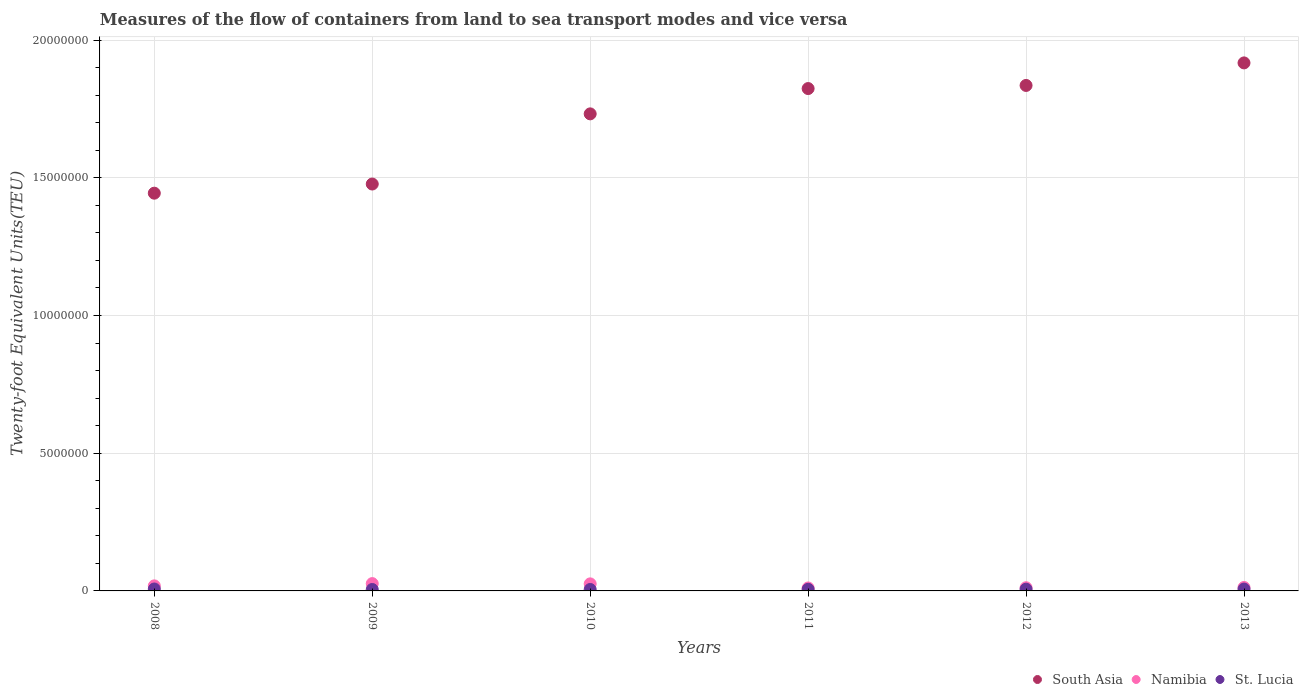What is the container port traffic in Namibia in 2011?
Make the answer very short. 1.08e+05. Across all years, what is the maximum container port traffic in South Asia?
Provide a short and direct response. 1.92e+07. Across all years, what is the minimum container port traffic in Namibia?
Your answer should be very brief. 1.08e+05. In which year was the container port traffic in South Asia minimum?
Your answer should be very brief. 2008. What is the total container port traffic in St. Lucia in the graph?
Offer a terse response. 3.64e+05. What is the difference between the container port traffic in South Asia in 2012 and that in 2013?
Offer a terse response. -8.18e+05. What is the difference between the container port traffic in Namibia in 2013 and the container port traffic in South Asia in 2012?
Give a very brief answer. -1.82e+07. What is the average container port traffic in Namibia per year?
Provide a short and direct response. 1.76e+05. In the year 2009, what is the difference between the container port traffic in South Asia and container port traffic in St. Lucia?
Make the answer very short. 1.47e+07. What is the ratio of the container port traffic in South Asia in 2008 to that in 2012?
Provide a succinct answer. 0.79. What is the difference between the highest and the second highest container port traffic in St. Lucia?
Your answer should be very brief. 2301.22. What is the difference between the highest and the lowest container port traffic in Namibia?
Ensure brevity in your answer.  1.58e+05. Is the sum of the container port traffic in Namibia in 2009 and 2012 greater than the maximum container port traffic in South Asia across all years?
Ensure brevity in your answer.  No. Is the container port traffic in South Asia strictly greater than the container port traffic in Namibia over the years?
Provide a succinct answer. Yes. Is the container port traffic in St. Lucia strictly less than the container port traffic in Namibia over the years?
Make the answer very short. Yes. How many dotlines are there?
Provide a succinct answer. 3. Are the values on the major ticks of Y-axis written in scientific E-notation?
Offer a terse response. No. Does the graph contain grids?
Your answer should be very brief. Yes. How are the legend labels stacked?
Offer a very short reply. Horizontal. What is the title of the graph?
Offer a terse response. Measures of the flow of containers from land to sea transport modes and vice versa. What is the label or title of the X-axis?
Your answer should be compact. Years. What is the label or title of the Y-axis?
Your answer should be very brief. Twenty-foot Equivalent Units(TEU). What is the Twenty-foot Equivalent Units(TEU) of South Asia in 2008?
Provide a short and direct response. 1.44e+07. What is the Twenty-foot Equivalent Units(TEU) in Namibia in 2008?
Give a very brief answer. 1.84e+05. What is the Twenty-foot Equivalent Units(TEU) in St. Lucia in 2008?
Provide a short and direct response. 7.02e+04. What is the Twenty-foot Equivalent Units(TEU) of South Asia in 2009?
Offer a very short reply. 1.48e+07. What is the Twenty-foot Equivalent Units(TEU) of Namibia in 2009?
Your answer should be compact. 2.66e+05. What is the Twenty-foot Equivalent Units(TEU) in St. Lucia in 2009?
Your answer should be compact. 5.19e+04. What is the Twenty-foot Equivalent Units(TEU) of South Asia in 2010?
Provide a short and direct response. 1.73e+07. What is the Twenty-foot Equivalent Units(TEU) in Namibia in 2010?
Your response must be concise. 2.56e+05. What is the Twenty-foot Equivalent Units(TEU) of St. Lucia in 2010?
Provide a succinct answer. 5.25e+04. What is the Twenty-foot Equivalent Units(TEU) in South Asia in 2011?
Give a very brief answer. 1.82e+07. What is the Twenty-foot Equivalent Units(TEU) in Namibia in 2011?
Your answer should be very brief. 1.08e+05. What is the Twenty-foot Equivalent Units(TEU) of St. Lucia in 2011?
Your response must be concise. 5.85e+04. What is the Twenty-foot Equivalent Units(TEU) of South Asia in 2012?
Your response must be concise. 1.84e+07. What is the Twenty-foot Equivalent Units(TEU) of Namibia in 2012?
Keep it short and to the point. 1.16e+05. What is the Twenty-foot Equivalent Units(TEU) of St. Lucia in 2012?
Your answer should be very brief. 6.29e+04. What is the Twenty-foot Equivalent Units(TEU) of South Asia in 2013?
Your response must be concise. 1.92e+07. What is the Twenty-foot Equivalent Units(TEU) of Namibia in 2013?
Your answer should be compact. 1.25e+05. What is the Twenty-foot Equivalent Units(TEU) of St. Lucia in 2013?
Give a very brief answer. 6.79e+04. Across all years, what is the maximum Twenty-foot Equivalent Units(TEU) in South Asia?
Offer a very short reply. 1.92e+07. Across all years, what is the maximum Twenty-foot Equivalent Units(TEU) in Namibia?
Offer a terse response. 2.66e+05. Across all years, what is the maximum Twenty-foot Equivalent Units(TEU) of St. Lucia?
Provide a short and direct response. 7.02e+04. Across all years, what is the minimum Twenty-foot Equivalent Units(TEU) of South Asia?
Provide a succinct answer. 1.44e+07. Across all years, what is the minimum Twenty-foot Equivalent Units(TEU) of Namibia?
Your response must be concise. 1.08e+05. Across all years, what is the minimum Twenty-foot Equivalent Units(TEU) in St. Lucia?
Your answer should be very brief. 5.19e+04. What is the total Twenty-foot Equivalent Units(TEU) in South Asia in the graph?
Your response must be concise. 1.02e+08. What is the total Twenty-foot Equivalent Units(TEU) of Namibia in the graph?
Provide a succinct answer. 1.05e+06. What is the total Twenty-foot Equivalent Units(TEU) of St. Lucia in the graph?
Your response must be concise. 3.64e+05. What is the difference between the Twenty-foot Equivalent Units(TEU) in South Asia in 2008 and that in 2009?
Your answer should be very brief. -3.32e+05. What is the difference between the Twenty-foot Equivalent Units(TEU) of Namibia in 2008 and that in 2009?
Offer a very short reply. -8.21e+04. What is the difference between the Twenty-foot Equivalent Units(TEU) in St. Lucia in 2008 and that in 2009?
Provide a succinct answer. 1.83e+04. What is the difference between the Twenty-foot Equivalent Units(TEU) of South Asia in 2008 and that in 2010?
Provide a succinct answer. -2.88e+06. What is the difference between the Twenty-foot Equivalent Units(TEU) in Namibia in 2008 and that in 2010?
Ensure brevity in your answer.  -7.27e+04. What is the difference between the Twenty-foot Equivalent Units(TEU) of St. Lucia in 2008 and that in 2010?
Make the answer very short. 1.77e+04. What is the difference between the Twenty-foot Equivalent Units(TEU) in South Asia in 2008 and that in 2011?
Provide a succinct answer. -3.80e+06. What is the difference between the Twenty-foot Equivalent Units(TEU) in Namibia in 2008 and that in 2011?
Your answer should be compact. 7.60e+04. What is the difference between the Twenty-foot Equivalent Units(TEU) in St. Lucia in 2008 and that in 2011?
Offer a terse response. 1.17e+04. What is the difference between the Twenty-foot Equivalent Units(TEU) of South Asia in 2008 and that in 2012?
Offer a terse response. -3.91e+06. What is the difference between the Twenty-foot Equivalent Units(TEU) in Namibia in 2008 and that in 2012?
Your answer should be very brief. 6.79e+04. What is the difference between the Twenty-foot Equivalent Units(TEU) in St. Lucia in 2008 and that in 2012?
Keep it short and to the point. 7272.64. What is the difference between the Twenty-foot Equivalent Units(TEU) of South Asia in 2008 and that in 2013?
Give a very brief answer. -4.73e+06. What is the difference between the Twenty-foot Equivalent Units(TEU) of Namibia in 2008 and that in 2013?
Provide a short and direct response. 5.88e+04. What is the difference between the Twenty-foot Equivalent Units(TEU) in St. Lucia in 2008 and that in 2013?
Make the answer very short. 2301.22. What is the difference between the Twenty-foot Equivalent Units(TEU) of South Asia in 2009 and that in 2010?
Ensure brevity in your answer.  -2.55e+06. What is the difference between the Twenty-foot Equivalent Units(TEU) of Namibia in 2009 and that in 2010?
Offer a very short reply. 9344. What is the difference between the Twenty-foot Equivalent Units(TEU) of St. Lucia in 2009 and that in 2010?
Offer a terse response. -537. What is the difference between the Twenty-foot Equivalent Units(TEU) of South Asia in 2009 and that in 2011?
Give a very brief answer. -3.47e+06. What is the difference between the Twenty-foot Equivalent Units(TEU) of Namibia in 2009 and that in 2011?
Make the answer very short. 1.58e+05. What is the difference between the Twenty-foot Equivalent Units(TEU) in St. Lucia in 2009 and that in 2011?
Make the answer very short. -6596.94. What is the difference between the Twenty-foot Equivalent Units(TEU) in South Asia in 2009 and that in 2012?
Your response must be concise. -3.58e+06. What is the difference between the Twenty-foot Equivalent Units(TEU) in Namibia in 2009 and that in 2012?
Your answer should be very brief. 1.50e+05. What is the difference between the Twenty-foot Equivalent Units(TEU) of St. Lucia in 2009 and that in 2012?
Offer a very short reply. -1.10e+04. What is the difference between the Twenty-foot Equivalent Units(TEU) of South Asia in 2009 and that in 2013?
Provide a short and direct response. -4.40e+06. What is the difference between the Twenty-foot Equivalent Units(TEU) in Namibia in 2009 and that in 2013?
Offer a very short reply. 1.41e+05. What is the difference between the Twenty-foot Equivalent Units(TEU) in St. Lucia in 2009 and that in 2013?
Ensure brevity in your answer.  -1.60e+04. What is the difference between the Twenty-foot Equivalent Units(TEU) of South Asia in 2010 and that in 2011?
Your answer should be compact. -9.19e+05. What is the difference between the Twenty-foot Equivalent Units(TEU) in Namibia in 2010 and that in 2011?
Provide a short and direct response. 1.49e+05. What is the difference between the Twenty-foot Equivalent Units(TEU) of St. Lucia in 2010 and that in 2011?
Make the answer very short. -6059.94. What is the difference between the Twenty-foot Equivalent Units(TEU) of South Asia in 2010 and that in 2012?
Offer a terse response. -1.03e+06. What is the difference between the Twenty-foot Equivalent Units(TEU) in Namibia in 2010 and that in 2012?
Ensure brevity in your answer.  1.41e+05. What is the difference between the Twenty-foot Equivalent Units(TEU) in St. Lucia in 2010 and that in 2012?
Your response must be concise. -1.05e+04. What is the difference between the Twenty-foot Equivalent Units(TEU) in South Asia in 2010 and that in 2013?
Give a very brief answer. -1.85e+06. What is the difference between the Twenty-foot Equivalent Units(TEU) of Namibia in 2010 and that in 2013?
Provide a short and direct response. 1.32e+05. What is the difference between the Twenty-foot Equivalent Units(TEU) of St. Lucia in 2010 and that in 2013?
Provide a succinct answer. -1.54e+04. What is the difference between the Twenty-foot Equivalent Units(TEU) of South Asia in 2011 and that in 2012?
Ensure brevity in your answer.  -1.13e+05. What is the difference between the Twenty-foot Equivalent Units(TEU) of Namibia in 2011 and that in 2012?
Ensure brevity in your answer.  -8070.45. What is the difference between the Twenty-foot Equivalent Units(TEU) of St. Lucia in 2011 and that in 2012?
Your answer should be very brief. -4390.42. What is the difference between the Twenty-foot Equivalent Units(TEU) in South Asia in 2011 and that in 2013?
Ensure brevity in your answer.  -9.32e+05. What is the difference between the Twenty-foot Equivalent Units(TEU) of Namibia in 2011 and that in 2013?
Give a very brief answer. -1.72e+04. What is the difference between the Twenty-foot Equivalent Units(TEU) of St. Lucia in 2011 and that in 2013?
Provide a succinct answer. -9361.84. What is the difference between the Twenty-foot Equivalent Units(TEU) of South Asia in 2012 and that in 2013?
Provide a short and direct response. -8.18e+05. What is the difference between the Twenty-foot Equivalent Units(TEU) in Namibia in 2012 and that in 2013?
Offer a very short reply. -9138.44. What is the difference between the Twenty-foot Equivalent Units(TEU) of St. Lucia in 2012 and that in 2013?
Offer a terse response. -4971.42. What is the difference between the Twenty-foot Equivalent Units(TEU) in South Asia in 2008 and the Twenty-foot Equivalent Units(TEU) in Namibia in 2009?
Ensure brevity in your answer.  1.42e+07. What is the difference between the Twenty-foot Equivalent Units(TEU) in South Asia in 2008 and the Twenty-foot Equivalent Units(TEU) in St. Lucia in 2009?
Make the answer very short. 1.44e+07. What is the difference between the Twenty-foot Equivalent Units(TEU) of Namibia in 2008 and the Twenty-foot Equivalent Units(TEU) of St. Lucia in 2009?
Your response must be concise. 1.32e+05. What is the difference between the Twenty-foot Equivalent Units(TEU) of South Asia in 2008 and the Twenty-foot Equivalent Units(TEU) of Namibia in 2010?
Your answer should be very brief. 1.42e+07. What is the difference between the Twenty-foot Equivalent Units(TEU) in South Asia in 2008 and the Twenty-foot Equivalent Units(TEU) in St. Lucia in 2010?
Keep it short and to the point. 1.44e+07. What is the difference between the Twenty-foot Equivalent Units(TEU) of Namibia in 2008 and the Twenty-foot Equivalent Units(TEU) of St. Lucia in 2010?
Your answer should be compact. 1.31e+05. What is the difference between the Twenty-foot Equivalent Units(TEU) of South Asia in 2008 and the Twenty-foot Equivalent Units(TEU) of Namibia in 2011?
Give a very brief answer. 1.43e+07. What is the difference between the Twenty-foot Equivalent Units(TEU) in South Asia in 2008 and the Twenty-foot Equivalent Units(TEU) in St. Lucia in 2011?
Give a very brief answer. 1.44e+07. What is the difference between the Twenty-foot Equivalent Units(TEU) of Namibia in 2008 and the Twenty-foot Equivalent Units(TEU) of St. Lucia in 2011?
Give a very brief answer. 1.25e+05. What is the difference between the Twenty-foot Equivalent Units(TEU) in South Asia in 2008 and the Twenty-foot Equivalent Units(TEU) in Namibia in 2012?
Provide a short and direct response. 1.43e+07. What is the difference between the Twenty-foot Equivalent Units(TEU) of South Asia in 2008 and the Twenty-foot Equivalent Units(TEU) of St. Lucia in 2012?
Provide a short and direct response. 1.44e+07. What is the difference between the Twenty-foot Equivalent Units(TEU) in Namibia in 2008 and the Twenty-foot Equivalent Units(TEU) in St. Lucia in 2012?
Ensure brevity in your answer.  1.21e+05. What is the difference between the Twenty-foot Equivalent Units(TEU) in South Asia in 2008 and the Twenty-foot Equivalent Units(TEU) in Namibia in 2013?
Your answer should be compact. 1.43e+07. What is the difference between the Twenty-foot Equivalent Units(TEU) of South Asia in 2008 and the Twenty-foot Equivalent Units(TEU) of St. Lucia in 2013?
Your response must be concise. 1.44e+07. What is the difference between the Twenty-foot Equivalent Units(TEU) of Namibia in 2008 and the Twenty-foot Equivalent Units(TEU) of St. Lucia in 2013?
Give a very brief answer. 1.16e+05. What is the difference between the Twenty-foot Equivalent Units(TEU) of South Asia in 2009 and the Twenty-foot Equivalent Units(TEU) of Namibia in 2010?
Your answer should be compact. 1.45e+07. What is the difference between the Twenty-foot Equivalent Units(TEU) of South Asia in 2009 and the Twenty-foot Equivalent Units(TEU) of St. Lucia in 2010?
Give a very brief answer. 1.47e+07. What is the difference between the Twenty-foot Equivalent Units(TEU) of Namibia in 2009 and the Twenty-foot Equivalent Units(TEU) of St. Lucia in 2010?
Offer a terse response. 2.13e+05. What is the difference between the Twenty-foot Equivalent Units(TEU) of South Asia in 2009 and the Twenty-foot Equivalent Units(TEU) of Namibia in 2011?
Provide a short and direct response. 1.47e+07. What is the difference between the Twenty-foot Equivalent Units(TEU) of South Asia in 2009 and the Twenty-foot Equivalent Units(TEU) of St. Lucia in 2011?
Offer a terse response. 1.47e+07. What is the difference between the Twenty-foot Equivalent Units(TEU) of Namibia in 2009 and the Twenty-foot Equivalent Units(TEU) of St. Lucia in 2011?
Offer a very short reply. 2.07e+05. What is the difference between the Twenty-foot Equivalent Units(TEU) in South Asia in 2009 and the Twenty-foot Equivalent Units(TEU) in Namibia in 2012?
Give a very brief answer. 1.47e+07. What is the difference between the Twenty-foot Equivalent Units(TEU) of South Asia in 2009 and the Twenty-foot Equivalent Units(TEU) of St. Lucia in 2012?
Keep it short and to the point. 1.47e+07. What is the difference between the Twenty-foot Equivalent Units(TEU) in Namibia in 2009 and the Twenty-foot Equivalent Units(TEU) in St. Lucia in 2012?
Your response must be concise. 2.03e+05. What is the difference between the Twenty-foot Equivalent Units(TEU) in South Asia in 2009 and the Twenty-foot Equivalent Units(TEU) in Namibia in 2013?
Offer a very short reply. 1.47e+07. What is the difference between the Twenty-foot Equivalent Units(TEU) in South Asia in 2009 and the Twenty-foot Equivalent Units(TEU) in St. Lucia in 2013?
Offer a very short reply. 1.47e+07. What is the difference between the Twenty-foot Equivalent Units(TEU) in Namibia in 2009 and the Twenty-foot Equivalent Units(TEU) in St. Lucia in 2013?
Provide a short and direct response. 1.98e+05. What is the difference between the Twenty-foot Equivalent Units(TEU) of South Asia in 2010 and the Twenty-foot Equivalent Units(TEU) of Namibia in 2011?
Provide a short and direct response. 1.72e+07. What is the difference between the Twenty-foot Equivalent Units(TEU) of South Asia in 2010 and the Twenty-foot Equivalent Units(TEU) of St. Lucia in 2011?
Offer a very short reply. 1.73e+07. What is the difference between the Twenty-foot Equivalent Units(TEU) of Namibia in 2010 and the Twenty-foot Equivalent Units(TEU) of St. Lucia in 2011?
Keep it short and to the point. 1.98e+05. What is the difference between the Twenty-foot Equivalent Units(TEU) in South Asia in 2010 and the Twenty-foot Equivalent Units(TEU) in Namibia in 2012?
Provide a short and direct response. 1.72e+07. What is the difference between the Twenty-foot Equivalent Units(TEU) of South Asia in 2010 and the Twenty-foot Equivalent Units(TEU) of St. Lucia in 2012?
Provide a short and direct response. 1.73e+07. What is the difference between the Twenty-foot Equivalent Units(TEU) in Namibia in 2010 and the Twenty-foot Equivalent Units(TEU) in St. Lucia in 2012?
Make the answer very short. 1.93e+05. What is the difference between the Twenty-foot Equivalent Units(TEU) of South Asia in 2010 and the Twenty-foot Equivalent Units(TEU) of Namibia in 2013?
Ensure brevity in your answer.  1.72e+07. What is the difference between the Twenty-foot Equivalent Units(TEU) of South Asia in 2010 and the Twenty-foot Equivalent Units(TEU) of St. Lucia in 2013?
Your answer should be very brief. 1.73e+07. What is the difference between the Twenty-foot Equivalent Units(TEU) of Namibia in 2010 and the Twenty-foot Equivalent Units(TEU) of St. Lucia in 2013?
Your answer should be compact. 1.88e+05. What is the difference between the Twenty-foot Equivalent Units(TEU) of South Asia in 2011 and the Twenty-foot Equivalent Units(TEU) of Namibia in 2012?
Your answer should be compact. 1.81e+07. What is the difference between the Twenty-foot Equivalent Units(TEU) in South Asia in 2011 and the Twenty-foot Equivalent Units(TEU) in St. Lucia in 2012?
Offer a terse response. 1.82e+07. What is the difference between the Twenty-foot Equivalent Units(TEU) of Namibia in 2011 and the Twenty-foot Equivalent Units(TEU) of St. Lucia in 2012?
Provide a succinct answer. 4.47e+04. What is the difference between the Twenty-foot Equivalent Units(TEU) in South Asia in 2011 and the Twenty-foot Equivalent Units(TEU) in Namibia in 2013?
Keep it short and to the point. 1.81e+07. What is the difference between the Twenty-foot Equivalent Units(TEU) of South Asia in 2011 and the Twenty-foot Equivalent Units(TEU) of St. Lucia in 2013?
Your response must be concise. 1.82e+07. What is the difference between the Twenty-foot Equivalent Units(TEU) in Namibia in 2011 and the Twenty-foot Equivalent Units(TEU) in St. Lucia in 2013?
Provide a succinct answer. 3.97e+04. What is the difference between the Twenty-foot Equivalent Units(TEU) of South Asia in 2012 and the Twenty-foot Equivalent Units(TEU) of Namibia in 2013?
Provide a succinct answer. 1.82e+07. What is the difference between the Twenty-foot Equivalent Units(TEU) in South Asia in 2012 and the Twenty-foot Equivalent Units(TEU) in St. Lucia in 2013?
Ensure brevity in your answer.  1.83e+07. What is the difference between the Twenty-foot Equivalent Units(TEU) in Namibia in 2012 and the Twenty-foot Equivalent Units(TEU) in St. Lucia in 2013?
Keep it short and to the point. 4.78e+04. What is the average Twenty-foot Equivalent Units(TEU) in South Asia per year?
Your answer should be compact. 1.71e+07. What is the average Twenty-foot Equivalent Units(TEU) of Namibia per year?
Give a very brief answer. 1.76e+05. What is the average Twenty-foot Equivalent Units(TEU) in St. Lucia per year?
Give a very brief answer. 6.07e+04. In the year 2008, what is the difference between the Twenty-foot Equivalent Units(TEU) of South Asia and Twenty-foot Equivalent Units(TEU) of Namibia?
Provide a succinct answer. 1.43e+07. In the year 2008, what is the difference between the Twenty-foot Equivalent Units(TEU) in South Asia and Twenty-foot Equivalent Units(TEU) in St. Lucia?
Your response must be concise. 1.44e+07. In the year 2008, what is the difference between the Twenty-foot Equivalent Units(TEU) of Namibia and Twenty-foot Equivalent Units(TEU) of St. Lucia?
Make the answer very short. 1.13e+05. In the year 2009, what is the difference between the Twenty-foot Equivalent Units(TEU) of South Asia and Twenty-foot Equivalent Units(TEU) of Namibia?
Give a very brief answer. 1.45e+07. In the year 2009, what is the difference between the Twenty-foot Equivalent Units(TEU) of South Asia and Twenty-foot Equivalent Units(TEU) of St. Lucia?
Your answer should be very brief. 1.47e+07. In the year 2009, what is the difference between the Twenty-foot Equivalent Units(TEU) in Namibia and Twenty-foot Equivalent Units(TEU) in St. Lucia?
Your answer should be compact. 2.14e+05. In the year 2010, what is the difference between the Twenty-foot Equivalent Units(TEU) of South Asia and Twenty-foot Equivalent Units(TEU) of Namibia?
Offer a very short reply. 1.71e+07. In the year 2010, what is the difference between the Twenty-foot Equivalent Units(TEU) in South Asia and Twenty-foot Equivalent Units(TEU) in St. Lucia?
Ensure brevity in your answer.  1.73e+07. In the year 2010, what is the difference between the Twenty-foot Equivalent Units(TEU) in Namibia and Twenty-foot Equivalent Units(TEU) in St. Lucia?
Provide a short and direct response. 2.04e+05. In the year 2011, what is the difference between the Twenty-foot Equivalent Units(TEU) of South Asia and Twenty-foot Equivalent Units(TEU) of Namibia?
Give a very brief answer. 1.81e+07. In the year 2011, what is the difference between the Twenty-foot Equivalent Units(TEU) in South Asia and Twenty-foot Equivalent Units(TEU) in St. Lucia?
Offer a very short reply. 1.82e+07. In the year 2011, what is the difference between the Twenty-foot Equivalent Units(TEU) in Namibia and Twenty-foot Equivalent Units(TEU) in St. Lucia?
Your response must be concise. 4.91e+04. In the year 2012, what is the difference between the Twenty-foot Equivalent Units(TEU) of South Asia and Twenty-foot Equivalent Units(TEU) of Namibia?
Ensure brevity in your answer.  1.82e+07. In the year 2012, what is the difference between the Twenty-foot Equivalent Units(TEU) of South Asia and Twenty-foot Equivalent Units(TEU) of St. Lucia?
Keep it short and to the point. 1.83e+07. In the year 2012, what is the difference between the Twenty-foot Equivalent Units(TEU) in Namibia and Twenty-foot Equivalent Units(TEU) in St. Lucia?
Your answer should be very brief. 5.27e+04. In the year 2013, what is the difference between the Twenty-foot Equivalent Units(TEU) in South Asia and Twenty-foot Equivalent Units(TEU) in Namibia?
Ensure brevity in your answer.  1.90e+07. In the year 2013, what is the difference between the Twenty-foot Equivalent Units(TEU) of South Asia and Twenty-foot Equivalent Units(TEU) of St. Lucia?
Offer a terse response. 1.91e+07. In the year 2013, what is the difference between the Twenty-foot Equivalent Units(TEU) in Namibia and Twenty-foot Equivalent Units(TEU) in St. Lucia?
Offer a terse response. 5.69e+04. What is the ratio of the Twenty-foot Equivalent Units(TEU) of South Asia in 2008 to that in 2009?
Your answer should be compact. 0.98. What is the ratio of the Twenty-foot Equivalent Units(TEU) in Namibia in 2008 to that in 2009?
Keep it short and to the point. 0.69. What is the ratio of the Twenty-foot Equivalent Units(TEU) of St. Lucia in 2008 to that in 2009?
Ensure brevity in your answer.  1.35. What is the ratio of the Twenty-foot Equivalent Units(TEU) in South Asia in 2008 to that in 2010?
Give a very brief answer. 0.83. What is the ratio of the Twenty-foot Equivalent Units(TEU) of Namibia in 2008 to that in 2010?
Ensure brevity in your answer.  0.72. What is the ratio of the Twenty-foot Equivalent Units(TEU) of St. Lucia in 2008 to that in 2010?
Your response must be concise. 1.34. What is the ratio of the Twenty-foot Equivalent Units(TEU) in South Asia in 2008 to that in 2011?
Make the answer very short. 0.79. What is the ratio of the Twenty-foot Equivalent Units(TEU) in Namibia in 2008 to that in 2011?
Provide a succinct answer. 1.71. What is the ratio of the Twenty-foot Equivalent Units(TEU) in St. Lucia in 2008 to that in 2011?
Ensure brevity in your answer.  1.2. What is the ratio of the Twenty-foot Equivalent Units(TEU) of South Asia in 2008 to that in 2012?
Provide a succinct answer. 0.79. What is the ratio of the Twenty-foot Equivalent Units(TEU) in Namibia in 2008 to that in 2012?
Your response must be concise. 1.59. What is the ratio of the Twenty-foot Equivalent Units(TEU) of St. Lucia in 2008 to that in 2012?
Offer a very short reply. 1.12. What is the ratio of the Twenty-foot Equivalent Units(TEU) of South Asia in 2008 to that in 2013?
Provide a succinct answer. 0.75. What is the ratio of the Twenty-foot Equivalent Units(TEU) in Namibia in 2008 to that in 2013?
Offer a terse response. 1.47. What is the ratio of the Twenty-foot Equivalent Units(TEU) in St. Lucia in 2008 to that in 2013?
Your answer should be compact. 1.03. What is the ratio of the Twenty-foot Equivalent Units(TEU) in South Asia in 2009 to that in 2010?
Provide a succinct answer. 0.85. What is the ratio of the Twenty-foot Equivalent Units(TEU) in Namibia in 2009 to that in 2010?
Your answer should be very brief. 1.04. What is the ratio of the Twenty-foot Equivalent Units(TEU) in South Asia in 2009 to that in 2011?
Your answer should be compact. 0.81. What is the ratio of the Twenty-foot Equivalent Units(TEU) of Namibia in 2009 to that in 2011?
Offer a terse response. 2.47. What is the ratio of the Twenty-foot Equivalent Units(TEU) of St. Lucia in 2009 to that in 2011?
Ensure brevity in your answer.  0.89. What is the ratio of the Twenty-foot Equivalent Units(TEU) in South Asia in 2009 to that in 2012?
Make the answer very short. 0.81. What is the ratio of the Twenty-foot Equivalent Units(TEU) in Namibia in 2009 to that in 2012?
Your answer should be compact. 2.3. What is the ratio of the Twenty-foot Equivalent Units(TEU) of St. Lucia in 2009 to that in 2012?
Your answer should be very brief. 0.83. What is the ratio of the Twenty-foot Equivalent Units(TEU) in South Asia in 2009 to that in 2013?
Your response must be concise. 0.77. What is the ratio of the Twenty-foot Equivalent Units(TEU) of Namibia in 2009 to that in 2013?
Make the answer very short. 2.13. What is the ratio of the Twenty-foot Equivalent Units(TEU) of St. Lucia in 2009 to that in 2013?
Your response must be concise. 0.77. What is the ratio of the Twenty-foot Equivalent Units(TEU) in South Asia in 2010 to that in 2011?
Your answer should be compact. 0.95. What is the ratio of the Twenty-foot Equivalent Units(TEU) of Namibia in 2010 to that in 2011?
Your response must be concise. 2.38. What is the ratio of the Twenty-foot Equivalent Units(TEU) of St. Lucia in 2010 to that in 2011?
Your answer should be compact. 0.9. What is the ratio of the Twenty-foot Equivalent Units(TEU) in South Asia in 2010 to that in 2012?
Offer a very short reply. 0.94. What is the ratio of the Twenty-foot Equivalent Units(TEU) in Namibia in 2010 to that in 2012?
Provide a short and direct response. 2.22. What is the ratio of the Twenty-foot Equivalent Units(TEU) in St. Lucia in 2010 to that in 2012?
Your answer should be very brief. 0.83. What is the ratio of the Twenty-foot Equivalent Units(TEU) of South Asia in 2010 to that in 2013?
Offer a terse response. 0.9. What is the ratio of the Twenty-foot Equivalent Units(TEU) in Namibia in 2010 to that in 2013?
Give a very brief answer. 2.05. What is the ratio of the Twenty-foot Equivalent Units(TEU) of St. Lucia in 2010 to that in 2013?
Your response must be concise. 0.77. What is the ratio of the Twenty-foot Equivalent Units(TEU) in South Asia in 2011 to that in 2012?
Your response must be concise. 0.99. What is the ratio of the Twenty-foot Equivalent Units(TEU) in Namibia in 2011 to that in 2012?
Offer a very short reply. 0.93. What is the ratio of the Twenty-foot Equivalent Units(TEU) of St. Lucia in 2011 to that in 2012?
Keep it short and to the point. 0.93. What is the ratio of the Twenty-foot Equivalent Units(TEU) in South Asia in 2011 to that in 2013?
Provide a short and direct response. 0.95. What is the ratio of the Twenty-foot Equivalent Units(TEU) in Namibia in 2011 to that in 2013?
Keep it short and to the point. 0.86. What is the ratio of the Twenty-foot Equivalent Units(TEU) of St. Lucia in 2011 to that in 2013?
Ensure brevity in your answer.  0.86. What is the ratio of the Twenty-foot Equivalent Units(TEU) of South Asia in 2012 to that in 2013?
Keep it short and to the point. 0.96. What is the ratio of the Twenty-foot Equivalent Units(TEU) in Namibia in 2012 to that in 2013?
Offer a terse response. 0.93. What is the ratio of the Twenty-foot Equivalent Units(TEU) of St. Lucia in 2012 to that in 2013?
Ensure brevity in your answer.  0.93. What is the difference between the highest and the second highest Twenty-foot Equivalent Units(TEU) in South Asia?
Keep it short and to the point. 8.18e+05. What is the difference between the highest and the second highest Twenty-foot Equivalent Units(TEU) of Namibia?
Offer a terse response. 9344. What is the difference between the highest and the second highest Twenty-foot Equivalent Units(TEU) in St. Lucia?
Give a very brief answer. 2301.22. What is the difference between the highest and the lowest Twenty-foot Equivalent Units(TEU) in South Asia?
Keep it short and to the point. 4.73e+06. What is the difference between the highest and the lowest Twenty-foot Equivalent Units(TEU) in Namibia?
Ensure brevity in your answer.  1.58e+05. What is the difference between the highest and the lowest Twenty-foot Equivalent Units(TEU) of St. Lucia?
Offer a very short reply. 1.83e+04. 